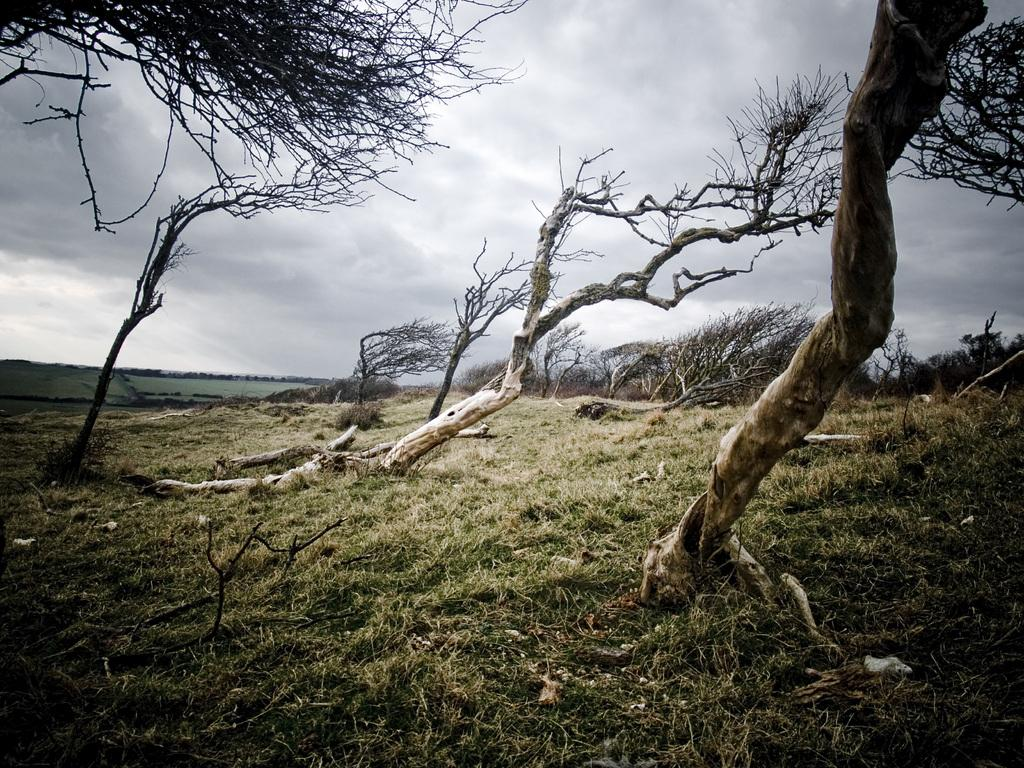What type of vegetation can be seen in the image? There is grass in the image. What else can be found on the ground in the image? Small stones are present in the image. What is the condition of the trees in the image? Bare trees are visible on the ground. What can be seen in the sky in the background of the image? Clouds are visible in the sky in the background of the image. Can you tell me how many giraffes are visible in the image? There are no giraffes present in the image. What type of horn can be seen on the trees in the image? There are no horns present on the trees in the image. 